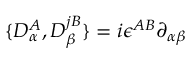Convert formula to latex. <formula><loc_0><loc_0><loc_500><loc_500>\{ D _ { \alpha } ^ { A } , D _ { \beta } ^ { j B } \} = i \epsilon ^ { A B } \partial _ { \alpha \beta }</formula> 